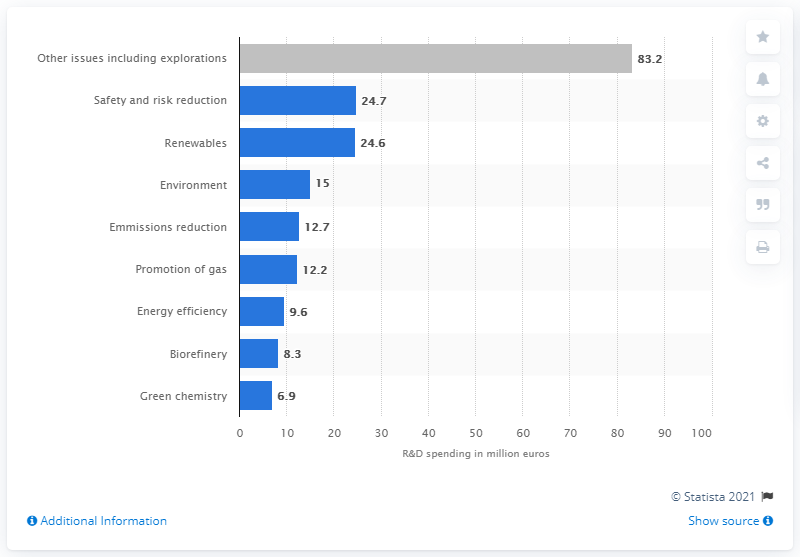Identify some key points in this picture. 24.7 billion dollars was invested in renewable energy in 2020. 